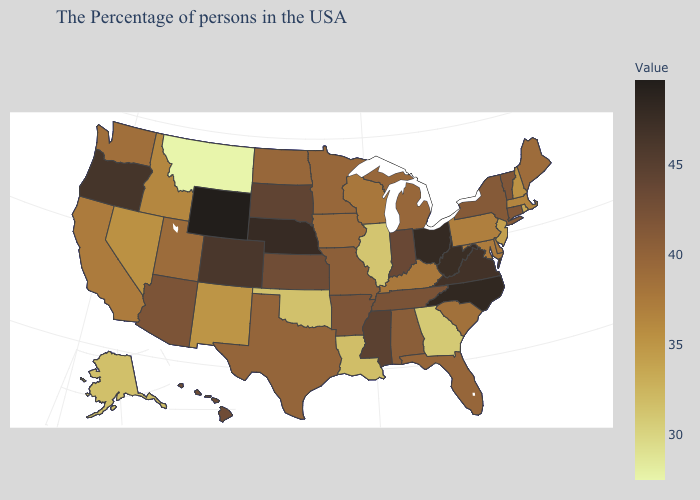Among the states that border Washington , which have the highest value?
Concise answer only. Oregon. Does Montana have the lowest value in the USA?
Short answer required. Yes. Does Nebraska have the lowest value in the MidWest?
Give a very brief answer. No. 